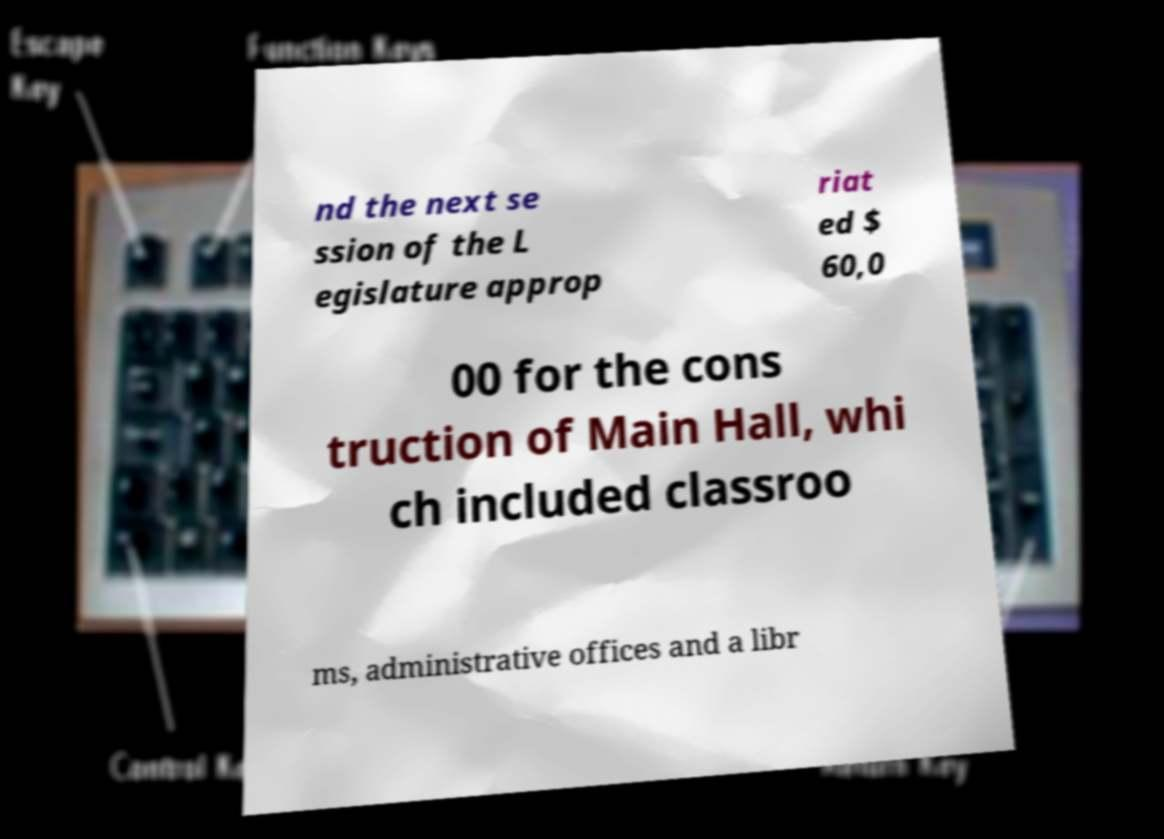Could you extract and type out the text from this image? nd the next se ssion of the L egislature approp riat ed $ 60,0 00 for the cons truction of Main Hall, whi ch included classroo ms, administrative offices and a libr 